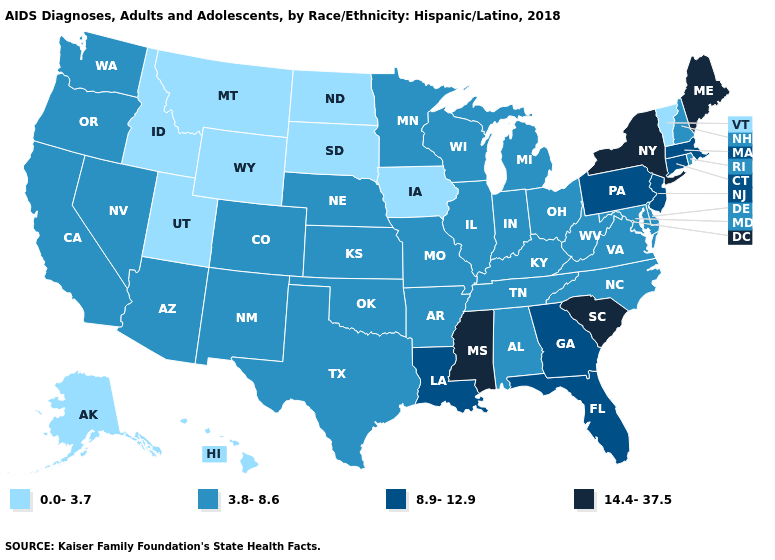Among the states that border Mississippi , which have the lowest value?
Answer briefly. Alabama, Arkansas, Tennessee. Among the states that border New York , does New Jersey have the lowest value?
Write a very short answer. No. Does South Dakota have a higher value than South Carolina?
Keep it brief. No. Does California have the highest value in the West?
Concise answer only. Yes. What is the highest value in states that border Delaware?
Short answer required. 8.9-12.9. Which states have the lowest value in the USA?
Quick response, please. Alaska, Hawaii, Idaho, Iowa, Montana, North Dakota, South Dakota, Utah, Vermont, Wyoming. What is the value of Massachusetts?
Quick response, please. 8.9-12.9. Does the map have missing data?
Be succinct. No. What is the value of Hawaii?
Write a very short answer. 0.0-3.7. Does New York have a higher value than Kentucky?
Be succinct. Yes. Does the map have missing data?
Keep it brief. No. Among the states that border Washington , does Oregon have the lowest value?
Keep it brief. No. What is the lowest value in the USA?
Short answer required. 0.0-3.7. Which states have the lowest value in the USA?
Keep it brief. Alaska, Hawaii, Idaho, Iowa, Montana, North Dakota, South Dakota, Utah, Vermont, Wyoming. Does the map have missing data?
Answer briefly. No. 